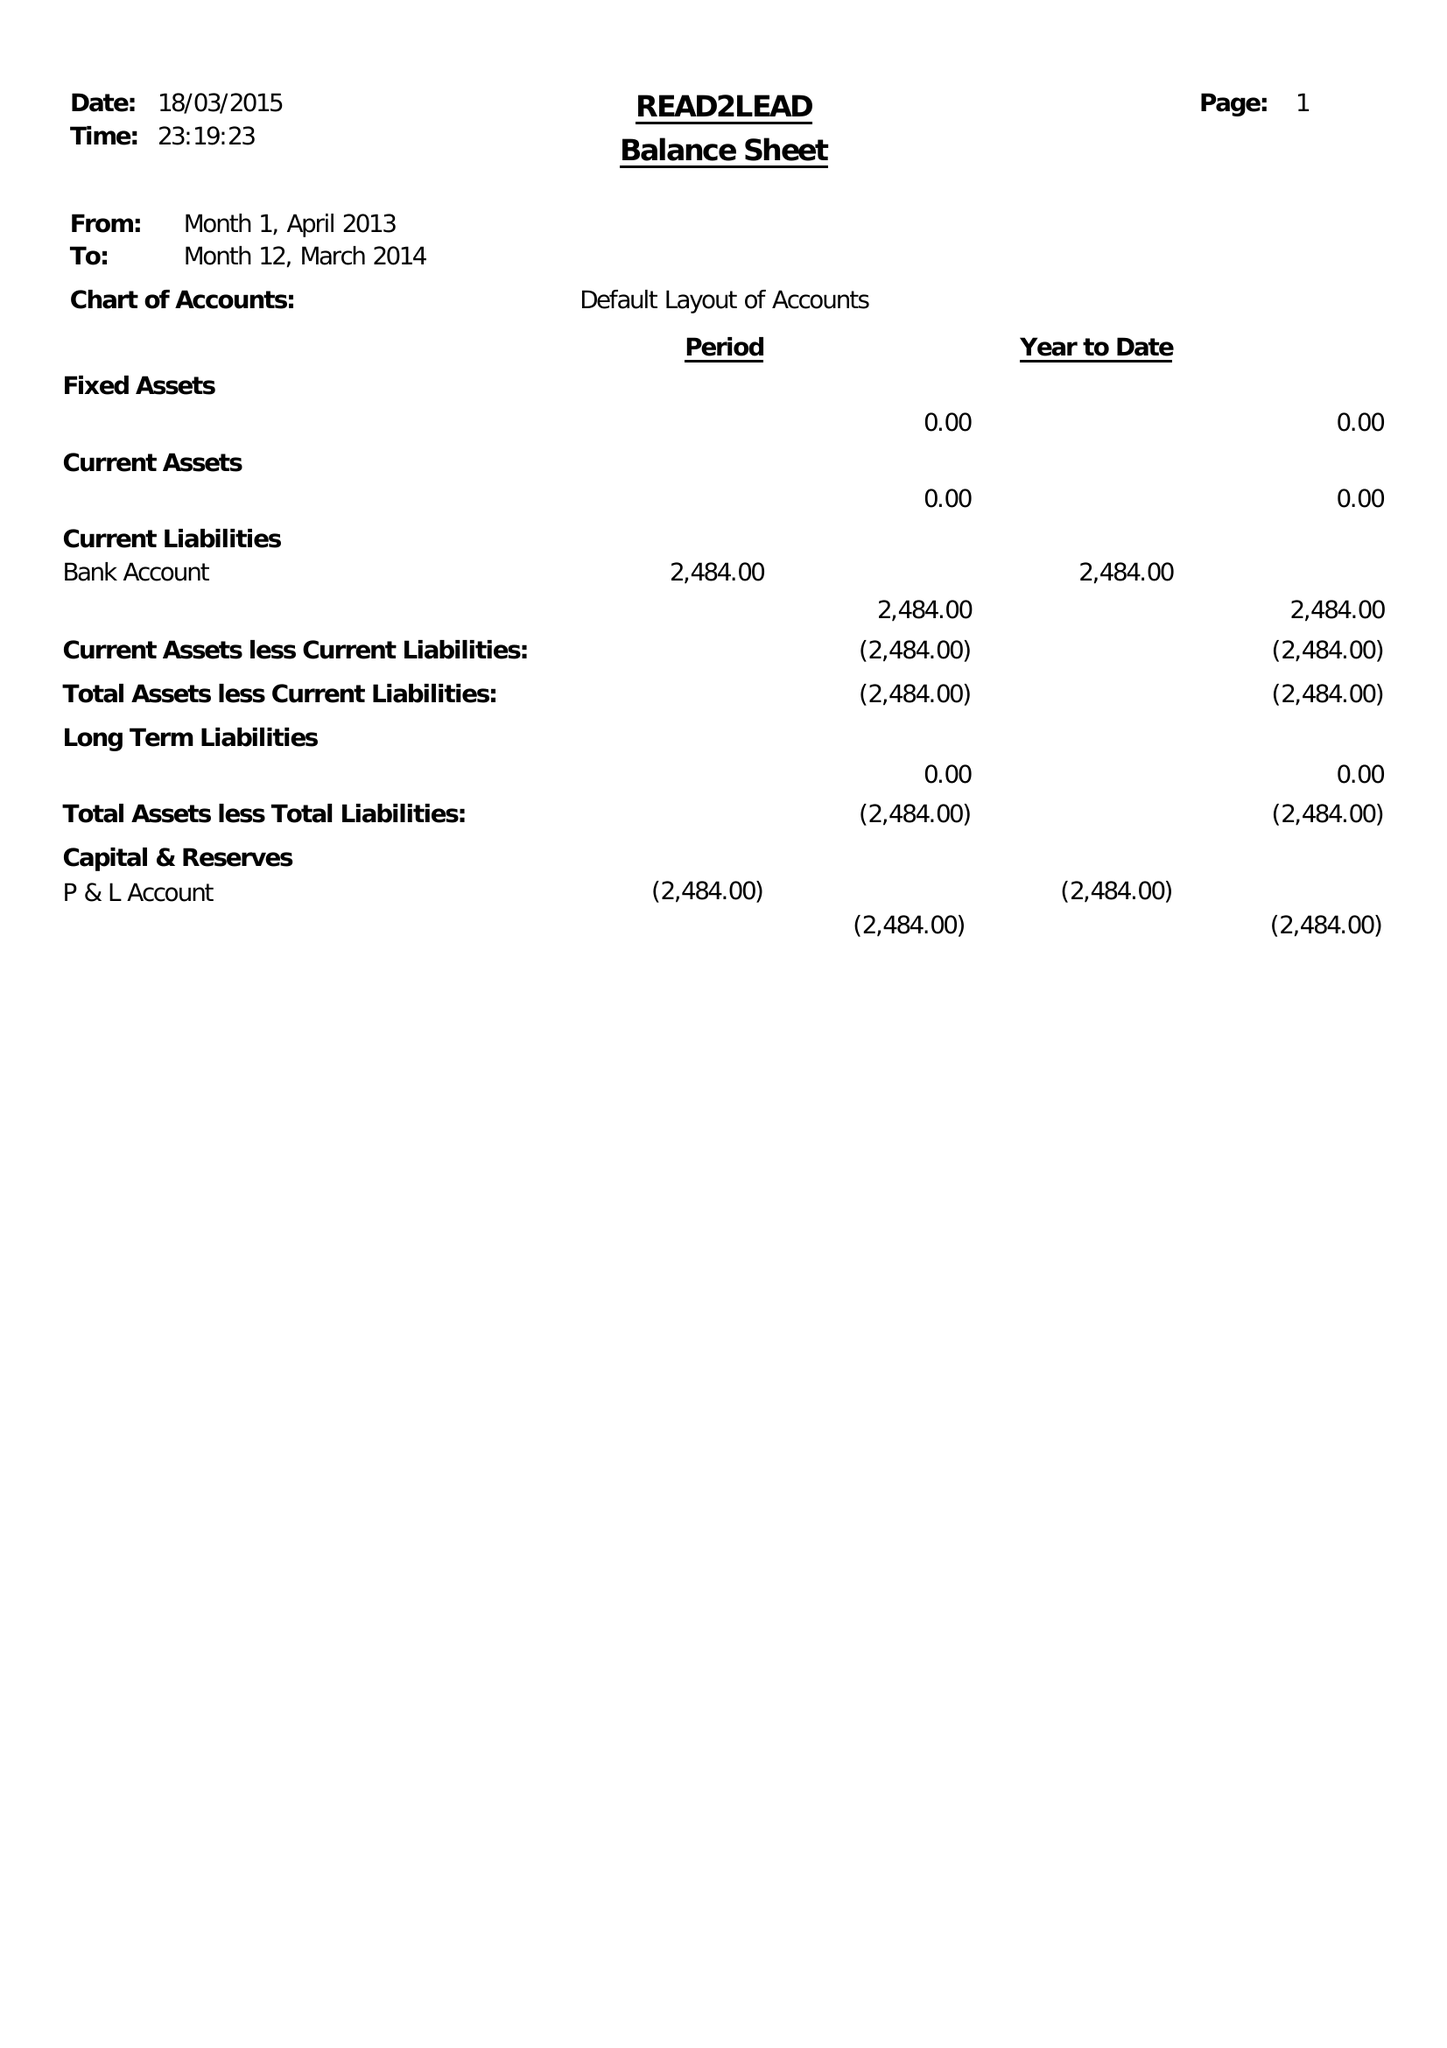What is the value for the income_annually_in_british_pounds?
Answer the question using a single word or phrase. 15750.00 